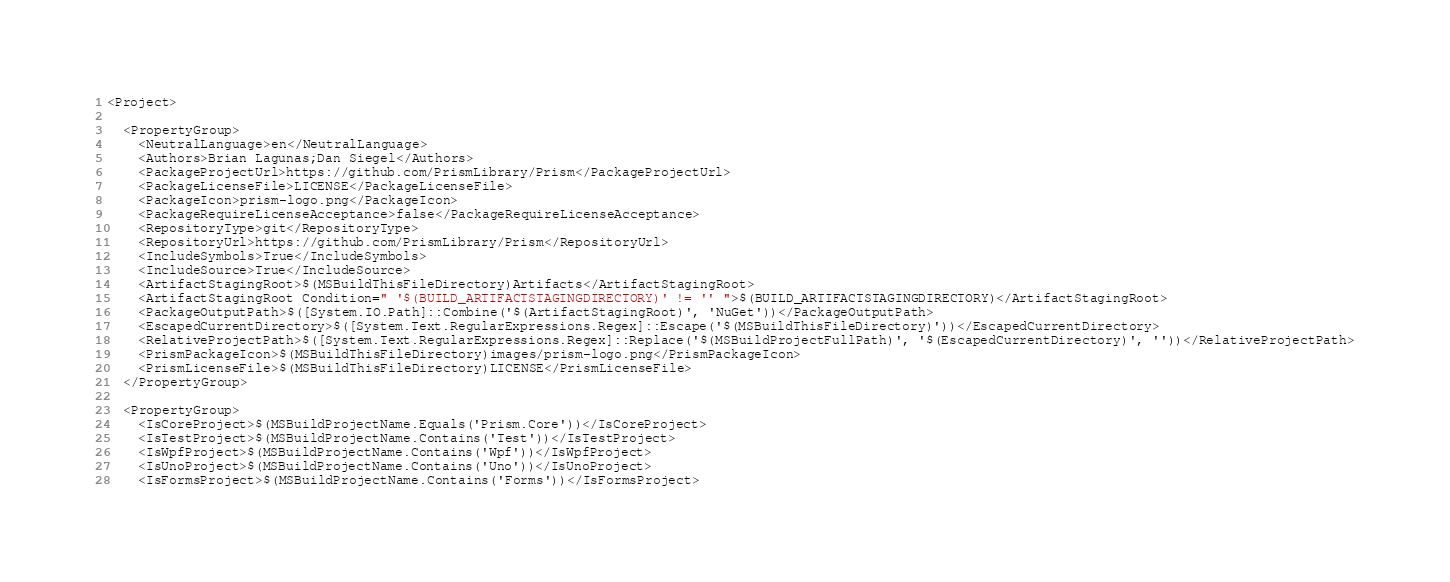Convert code to text. <code><loc_0><loc_0><loc_500><loc_500><_XML_><Project>

  <PropertyGroup>
    <NeutralLanguage>en</NeutralLanguage>
    <Authors>Brian Lagunas;Dan Siegel</Authors>
    <PackageProjectUrl>https://github.com/PrismLibrary/Prism</PackageProjectUrl>
    <PackageLicenseFile>LICENSE</PackageLicenseFile>
    <PackageIcon>prism-logo.png</PackageIcon>
    <PackageRequireLicenseAcceptance>false</PackageRequireLicenseAcceptance>
    <RepositoryType>git</RepositoryType>
    <RepositoryUrl>https://github.com/PrismLibrary/Prism</RepositoryUrl>
    <IncludeSymbols>True</IncludeSymbols>
    <IncludeSource>True</IncludeSource>
    <ArtifactStagingRoot>$(MSBuildThisFileDirectory)Artifacts</ArtifactStagingRoot>
    <ArtifactStagingRoot Condition=" '$(BUILD_ARTIFACTSTAGINGDIRECTORY)' != '' ">$(BUILD_ARTIFACTSTAGINGDIRECTORY)</ArtifactStagingRoot>
    <PackageOutputPath>$([System.IO.Path]::Combine('$(ArtifactStagingRoot)', 'NuGet'))</PackageOutputPath>
    <EscapedCurrentDirectory>$([System.Text.RegularExpressions.Regex]::Escape('$(MSBuildThisFileDirectory)'))</EscapedCurrentDirectory>
    <RelativeProjectPath>$([System.Text.RegularExpressions.Regex]::Replace('$(MSBuildProjectFullPath)', '$(EscapedCurrentDirectory)', ''))</RelativeProjectPath>
    <PrismPackageIcon>$(MSBuildThisFileDirectory)images/prism-logo.png</PrismPackageIcon>
    <PrismLicenseFile>$(MSBuildThisFileDirectory)LICENSE</PrismLicenseFile>
  </PropertyGroup>

  <PropertyGroup>
    <IsCoreProject>$(MSBuildProjectName.Equals('Prism.Core'))</IsCoreProject>
    <IsTestProject>$(MSBuildProjectName.Contains('Test'))</IsTestProject>
    <IsWpfProject>$(MSBuildProjectName.Contains('Wpf'))</IsWpfProject>
    <IsUnoProject>$(MSBuildProjectName.Contains('Uno'))</IsUnoProject>
    <IsFormsProject>$(MSBuildProjectName.Contains('Forms'))</IsFormsProject></code> 